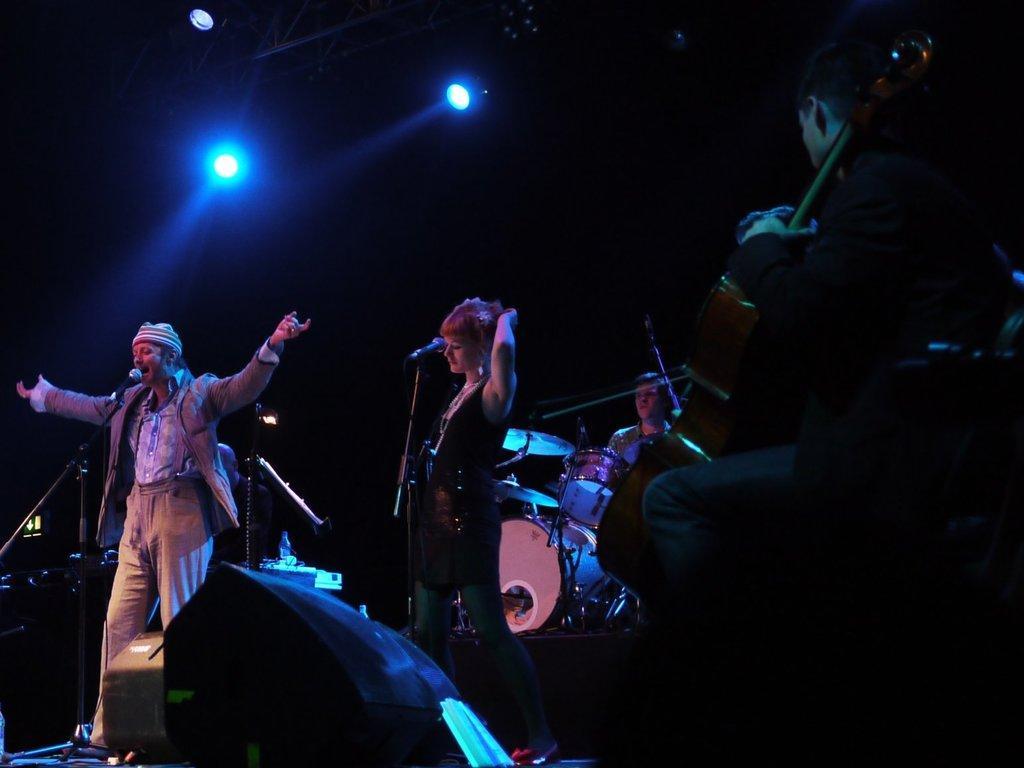Can you describe this image briefly? In this image there is a man standing and singing a song in the microphone , another woman standing near microphone , another man sitting and playing the drums , another man sitting and playing the violin and at the back ground there are focus lights, speaker, light. 